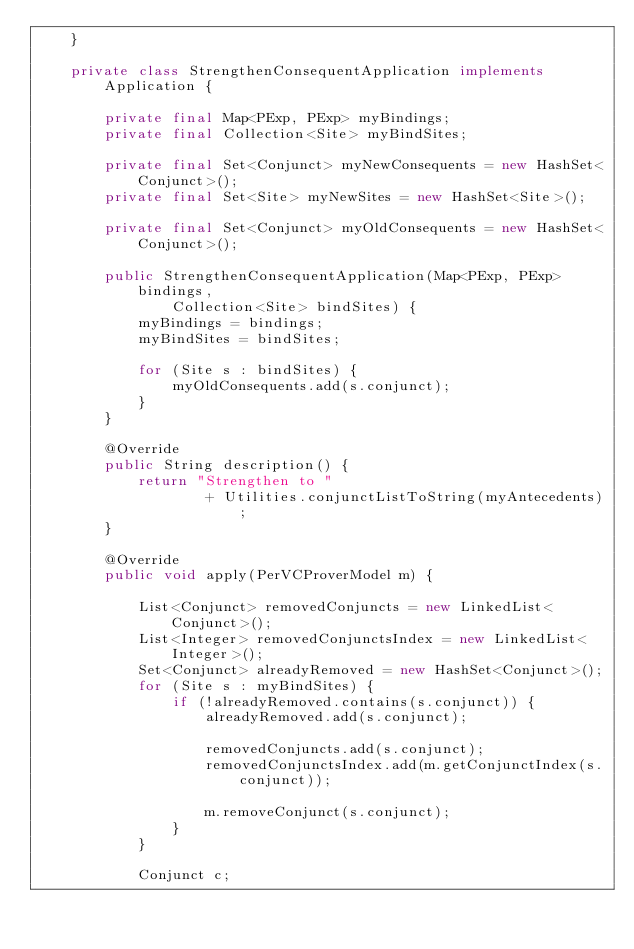<code> <loc_0><loc_0><loc_500><loc_500><_Java_>    }

    private class StrengthenConsequentApplication implements Application {

        private final Map<PExp, PExp> myBindings;
        private final Collection<Site> myBindSites;

        private final Set<Conjunct> myNewConsequents = new HashSet<Conjunct>();
        private final Set<Site> myNewSites = new HashSet<Site>();

        private final Set<Conjunct> myOldConsequents = new HashSet<Conjunct>();

        public StrengthenConsequentApplication(Map<PExp, PExp> bindings,
                Collection<Site> bindSites) {
            myBindings = bindings;
            myBindSites = bindSites;

            for (Site s : bindSites) {
                myOldConsequents.add(s.conjunct);
            }
        }

        @Override
        public String description() {
            return "Strengthen to "
                    + Utilities.conjunctListToString(myAntecedents);
        }

        @Override
        public void apply(PerVCProverModel m) {

            List<Conjunct> removedConjuncts = new LinkedList<Conjunct>();
            List<Integer> removedConjunctsIndex = new LinkedList<Integer>();
            Set<Conjunct> alreadyRemoved = new HashSet<Conjunct>();
            for (Site s : myBindSites) {
                if (!alreadyRemoved.contains(s.conjunct)) {
                    alreadyRemoved.add(s.conjunct);

                    removedConjuncts.add(s.conjunct);
                    removedConjunctsIndex.add(m.getConjunctIndex(s.conjunct));

                    m.removeConjunct(s.conjunct);
                }
            }

            Conjunct c;</code> 